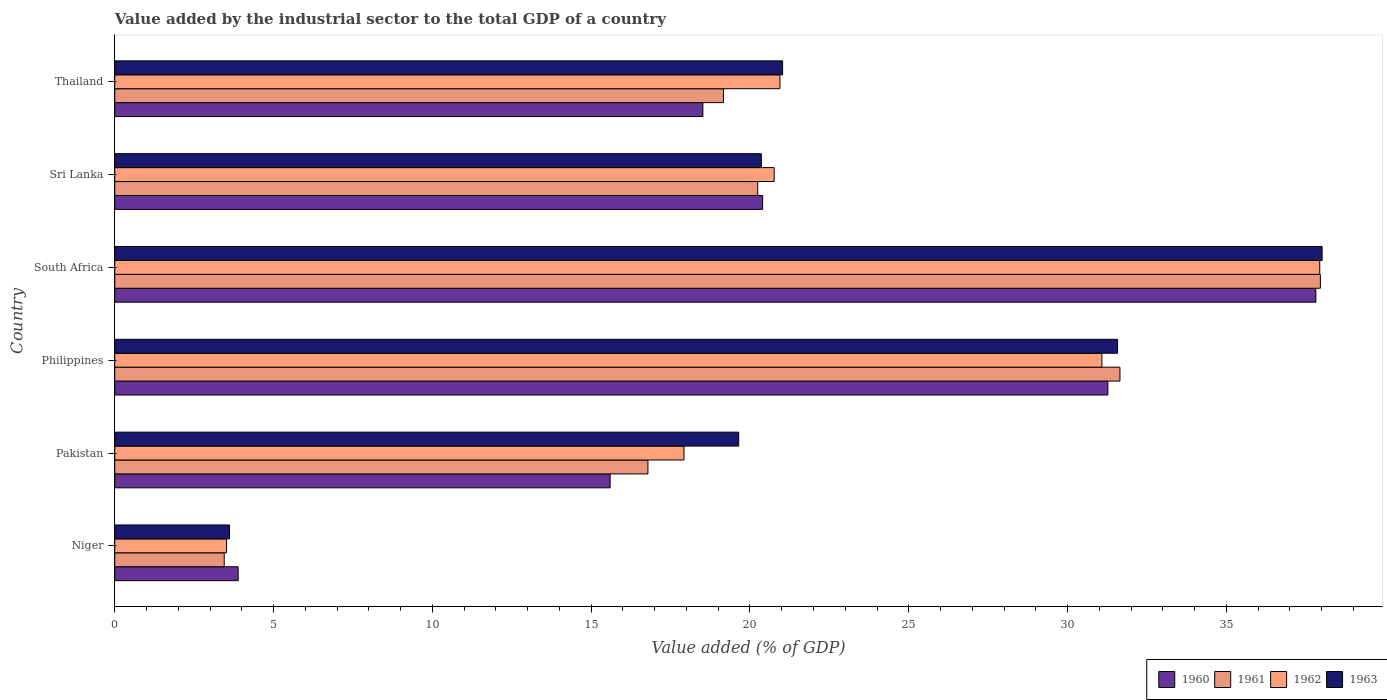How many groups of bars are there?
Ensure brevity in your answer.  6. Are the number of bars on each tick of the Y-axis equal?
Your response must be concise. Yes. How many bars are there on the 2nd tick from the top?
Give a very brief answer. 4. How many bars are there on the 2nd tick from the bottom?
Your answer should be compact. 4. What is the label of the 1st group of bars from the top?
Keep it short and to the point. Thailand. In how many cases, is the number of bars for a given country not equal to the number of legend labels?
Ensure brevity in your answer.  0. What is the value added by the industrial sector to the total GDP in 1962 in Thailand?
Give a very brief answer. 20.94. Across all countries, what is the maximum value added by the industrial sector to the total GDP in 1962?
Keep it short and to the point. 37.94. Across all countries, what is the minimum value added by the industrial sector to the total GDP in 1961?
Your answer should be very brief. 3.45. In which country was the value added by the industrial sector to the total GDP in 1961 maximum?
Your answer should be very brief. South Africa. In which country was the value added by the industrial sector to the total GDP in 1960 minimum?
Your answer should be compact. Niger. What is the total value added by the industrial sector to the total GDP in 1963 in the graph?
Your response must be concise. 134.23. What is the difference between the value added by the industrial sector to the total GDP in 1961 in Pakistan and that in Thailand?
Make the answer very short. -2.38. What is the difference between the value added by the industrial sector to the total GDP in 1960 in Niger and the value added by the industrial sector to the total GDP in 1961 in South Africa?
Offer a terse response. -34.07. What is the average value added by the industrial sector to the total GDP in 1960 per country?
Make the answer very short. 21.25. What is the difference between the value added by the industrial sector to the total GDP in 1963 and value added by the industrial sector to the total GDP in 1962 in Sri Lanka?
Provide a short and direct response. -0.4. What is the ratio of the value added by the industrial sector to the total GDP in 1960 in Philippines to that in Sri Lanka?
Your answer should be compact. 1.53. Is the value added by the industrial sector to the total GDP in 1961 in Pakistan less than that in Philippines?
Give a very brief answer. Yes. Is the difference between the value added by the industrial sector to the total GDP in 1963 in Niger and Philippines greater than the difference between the value added by the industrial sector to the total GDP in 1962 in Niger and Philippines?
Provide a succinct answer. No. What is the difference between the highest and the second highest value added by the industrial sector to the total GDP in 1963?
Make the answer very short. 6.44. What is the difference between the highest and the lowest value added by the industrial sector to the total GDP in 1962?
Offer a terse response. 34.42. In how many countries, is the value added by the industrial sector to the total GDP in 1960 greater than the average value added by the industrial sector to the total GDP in 1960 taken over all countries?
Keep it short and to the point. 2. Is it the case that in every country, the sum of the value added by the industrial sector to the total GDP in 1961 and value added by the industrial sector to the total GDP in 1960 is greater than the sum of value added by the industrial sector to the total GDP in 1963 and value added by the industrial sector to the total GDP in 1962?
Offer a very short reply. No. What does the 4th bar from the top in Philippines represents?
Offer a very short reply. 1960. Is it the case that in every country, the sum of the value added by the industrial sector to the total GDP in 1961 and value added by the industrial sector to the total GDP in 1962 is greater than the value added by the industrial sector to the total GDP in 1960?
Keep it short and to the point. Yes. How many bars are there?
Provide a short and direct response. 24. Does the graph contain any zero values?
Offer a very short reply. No. What is the title of the graph?
Provide a short and direct response. Value added by the industrial sector to the total GDP of a country. What is the label or title of the X-axis?
Your answer should be very brief. Value added (% of GDP). What is the label or title of the Y-axis?
Keep it short and to the point. Country. What is the Value added (% of GDP) in 1960 in Niger?
Offer a very short reply. 3.89. What is the Value added (% of GDP) of 1961 in Niger?
Provide a short and direct response. 3.45. What is the Value added (% of GDP) in 1962 in Niger?
Offer a terse response. 3.52. What is the Value added (% of GDP) of 1963 in Niger?
Offer a very short reply. 3.61. What is the Value added (% of GDP) of 1960 in Pakistan?
Offer a very short reply. 15.6. What is the Value added (% of GDP) of 1961 in Pakistan?
Give a very brief answer. 16.79. What is the Value added (% of GDP) in 1962 in Pakistan?
Keep it short and to the point. 17.92. What is the Value added (% of GDP) of 1963 in Pakistan?
Offer a terse response. 19.64. What is the Value added (% of GDP) in 1960 in Philippines?
Offer a terse response. 31.27. What is the Value added (% of GDP) of 1961 in Philippines?
Your answer should be compact. 31.65. What is the Value added (% of GDP) in 1962 in Philippines?
Make the answer very short. 31.08. What is the Value added (% of GDP) in 1963 in Philippines?
Give a very brief answer. 31.57. What is the Value added (% of GDP) in 1960 in South Africa?
Provide a short and direct response. 37.82. What is the Value added (% of GDP) in 1961 in South Africa?
Ensure brevity in your answer.  37.96. What is the Value added (% of GDP) in 1962 in South Africa?
Your response must be concise. 37.94. What is the Value added (% of GDP) in 1963 in South Africa?
Provide a short and direct response. 38.01. What is the Value added (% of GDP) of 1960 in Sri Lanka?
Keep it short and to the point. 20.4. What is the Value added (% of GDP) of 1961 in Sri Lanka?
Your answer should be very brief. 20.24. What is the Value added (% of GDP) in 1962 in Sri Lanka?
Your answer should be compact. 20.76. What is the Value added (% of GDP) in 1963 in Sri Lanka?
Offer a terse response. 20.36. What is the Value added (% of GDP) in 1960 in Thailand?
Provide a short and direct response. 18.52. What is the Value added (% of GDP) in 1961 in Thailand?
Your answer should be compact. 19.16. What is the Value added (% of GDP) in 1962 in Thailand?
Give a very brief answer. 20.94. What is the Value added (% of GDP) of 1963 in Thailand?
Your answer should be compact. 21.03. Across all countries, what is the maximum Value added (% of GDP) in 1960?
Offer a very short reply. 37.82. Across all countries, what is the maximum Value added (% of GDP) of 1961?
Give a very brief answer. 37.96. Across all countries, what is the maximum Value added (% of GDP) of 1962?
Give a very brief answer. 37.94. Across all countries, what is the maximum Value added (% of GDP) of 1963?
Keep it short and to the point. 38.01. Across all countries, what is the minimum Value added (% of GDP) of 1960?
Provide a succinct answer. 3.89. Across all countries, what is the minimum Value added (% of GDP) of 1961?
Ensure brevity in your answer.  3.45. Across all countries, what is the minimum Value added (% of GDP) of 1962?
Make the answer very short. 3.52. Across all countries, what is the minimum Value added (% of GDP) in 1963?
Your answer should be compact. 3.61. What is the total Value added (% of GDP) of 1960 in the graph?
Ensure brevity in your answer.  127.48. What is the total Value added (% of GDP) of 1961 in the graph?
Ensure brevity in your answer.  129.25. What is the total Value added (% of GDP) in 1962 in the graph?
Provide a short and direct response. 132.16. What is the total Value added (% of GDP) of 1963 in the graph?
Provide a succinct answer. 134.23. What is the difference between the Value added (% of GDP) in 1960 in Niger and that in Pakistan?
Provide a short and direct response. -11.71. What is the difference between the Value added (% of GDP) of 1961 in Niger and that in Pakistan?
Your answer should be compact. -13.34. What is the difference between the Value added (% of GDP) of 1962 in Niger and that in Pakistan?
Provide a succinct answer. -14.4. What is the difference between the Value added (% of GDP) in 1963 in Niger and that in Pakistan?
Ensure brevity in your answer.  -16.03. What is the difference between the Value added (% of GDP) in 1960 in Niger and that in Philippines?
Your answer should be compact. -27.38. What is the difference between the Value added (% of GDP) in 1961 in Niger and that in Philippines?
Ensure brevity in your answer.  -28.2. What is the difference between the Value added (% of GDP) in 1962 in Niger and that in Philippines?
Provide a succinct answer. -27.56. What is the difference between the Value added (% of GDP) in 1963 in Niger and that in Philippines?
Provide a short and direct response. -27.96. What is the difference between the Value added (% of GDP) in 1960 in Niger and that in South Africa?
Ensure brevity in your answer.  -33.93. What is the difference between the Value added (% of GDP) in 1961 in Niger and that in South Africa?
Your response must be concise. -34.51. What is the difference between the Value added (% of GDP) in 1962 in Niger and that in South Africa?
Provide a succinct answer. -34.42. What is the difference between the Value added (% of GDP) of 1963 in Niger and that in South Africa?
Your answer should be compact. -34.4. What is the difference between the Value added (% of GDP) of 1960 in Niger and that in Sri Lanka?
Provide a short and direct response. -16.51. What is the difference between the Value added (% of GDP) of 1961 in Niger and that in Sri Lanka?
Your response must be concise. -16.8. What is the difference between the Value added (% of GDP) in 1962 in Niger and that in Sri Lanka?
Ensure brevity in your answer.  -17.24. What is the difference between the Value added (% of GDP) in 1963 in Niger and that in Sri Lanka?
Your answer should be very brief. -16.74. What is the difference between the Value added (% of GDP) of 1960 in Niger and that in Thailand?
Offer a very short reply. -14.63. What is the difference between the Value added (% of GDP) of 1961 in Niger and that in Thailand?
Offer a very short reply. -15.72. What is the difference between the Value added (% of GDP) of 1962 in Niger and that in Thailand?
Your answer should be compact. -17.42. What is the difference between the Value added (% of GDP) of 1963 in Niger and that in Thailand?
Give a very brief answer. -17.41. What is the difference between the Value added (% of GDP) of 1960 in Pakistan and that in Philippines?
Make the answer very short. -15.67. What is the difference between the Value added (% of GDP) in 1961 in Pakistan and that in Philippines?
Provide a succinct answer. -14.86. What is the difference between the Value added (% of GDP) in 1962 in Pakistan and that in Philippines?
Ensure brevity in your answer.  -13.16. What is the difference between the Value added (% of GDP) of 1963 in Pakistan and that in Philippines?
Provide a succinct answer. -11.93. What is the difference between the Value added (% of GDP) of 1960 in Pakistan and that in South Africa?
Give a very brief answer. -22.22. What is the difference between the Value added (% of GDP) of 1961 in Pakistan and that in South Africa?
Offer a very short reply. -21.17. What is the difference between the Value added (% of GDP) in 1962 in Pakistan and that in South Africa?
Your answer should be very brief. -20.02. What is the difference between the Value added (% of GDP) of 1963 in Pakistan and that in South Africa?
Keep it short and to the point. -18.37. What is the difference between the Value added (% of GDP) of 1960 in Pakistan and that in Sri Lanka?
Keep it short and to the point. -4.8. What is the difference between the Value added (% of GDP) of 1961 in Pakistan and that in Sri Lanka?
Give a very brief answer. -3.46. What is the difference between the Value added (% of GDP) of 1962 in Pakistan and that in Sri Lanka?
Keep it short and to the point. -2.84. What is the difference between the Value added (% of GDP) in 1963 in Pakistan and that in Sri Lanka?
Ensure brevity in your answer.  -0.71. What is the difference between the Value added (% of GDP) in 1960 in Pakistan and that in Thailand?
Your answer should be very brief. -2.92. What is the difference between the Value added (% of GDP) of 1961 in Pakistan and that in Thailand?
Provide a short and direct response. -2.38. What is the difference between the Value added (% of GDP) of 1962 in Pakistan and that in Thailand?
Provide a succinct answer. -3.02. What is the difference between the Value added (% of GDP) of 1963 in Pakistan and that in Thailand?
Ensure brevity in your answer.  -1.38. What is the difference between the Value added (% of GDP) of 1960 in Philippines and that in South Africa?
Your answer should be compact. -6.55. What is the difference between the Value added (% of GDP) in 1961 in Philippines and that in South Africa?
Provide a short and direct response. -6.31. What is the difference between the Value added (% of GDP) of 1962 in Philippines and that in South Africa?
Provide a short and direct response. -6.86. What is the difference between the Value added (% of GDP) in 1963 in Philippines and that in South Africa?
Give a very brief answer. -6.44. What is the difference between the Value added (% of GDP) in 1960 in Philippines and that in Sri Lanka?
Ensure brevity in your answer.  10.87. What is the difference between the Value added (% of GDP) of 1961 in Philippines and that in Sri Lanka?
Give a very brief answer. 11.41. What is the difference between the Value added (% of GDP) in 1962 in Philippines and that in Sri Lanka?
Your answer should be compact. 10.32. What is the difference between the Value added (% of GDP) in 1963 in Philippines and that in Sri Lanka?
Ensure brevity in your answer.  11.22. What is the difference between the Value added (% of GDP) in 1960 in Philippines and that in Thailand?
Offer a terse response. 12.75. What is the difference between the Value added (% of GDP) of 1961 in Philippines and that in Thailand?
Offer a very short reply. 12.48. What is the difference between the Value added (% of GDP) of 1962 in Philippines and that in Thailand?
Your answer should be compact. 10.14. What is the difference between the Value added (% of GDP) in 1963 in Philippines and that in Thailand?
Offer a terse response. 10.55. What is the difference between the Value added (% of GDP) in 1960 in South Africa and that in Sri Lanka?
Your answer should be compact. 17.42. What is the difference between the Value added (% of GDP) in 1961 in South Africa and that in Sri Lanka?
Offer a terse response. 17.72. What is the difference between the Value added (% of GDP) in 1962 in South Africa and that in Sri Lanka?
Give a very brief answer. 17.18. What is the difference between the Value added (% of GDP) in 1963 in South Africa and that in Sri Lanka?
Provide a short and direct response. 17.66. What is the difference between the Value added (% of GDP) of 1960 in South Africa and that in Thailand?
Give a very brief answer. 19.3. What is the difference between the Value added (% of GDP) of 1961 in South Africa and that in Thailand?
Your response must be concise. 18.79. What is the difference between the Value added (% of GDP) of 1962 in South Africa and that in Thailand?
Offer a terse response. 17. What is the difference between the Value added (% of GDP) in 1963 in South Africa and that in Thailand?
Your answer should be compact. 16.99. What is the difference between the Value added (% of GDP) in 1960 in Sri Lanka and that in Thailand?
Provide a succinct answer. 1.88. What is the difference between the Value added (% of GDP) in 1961 in Sri Lanka and that in Thailand?
Make the answer very short. 1.08. What is the difference between the Value added (% of GDP) in 1962 in Sri Lanka and that in Thailand?
Your response must be concise. -0.18. What is the difference between the Value added (% of GDP) of 1963 in Sri Lanka and that in Thailand?
Your answer should be very brief. -0.67. What is the difference between the Value added (% of GDP) of 1960 in Niger and the Value added (% of GDP) of 1961 in Pakistan?
Offer a terse response. -12.9. What is the difference between the Value added (% of GDP) of 1960 in Niger and the Value added (% of GDP) of 1962 in Pakistan?
Provide a short and direct response. -14.04. What is the difference between the Value added (% of GDP) in 1960 in Niger and the Value added (% of GDP) in 1963 in Pakistan?
Make the answer very short. -15.76. What is the difference between the Value added (% of GDP) of 1961 in Niger and the Value added (% of GDP) of 1962 in Pakistan?
Your answer should be very brief. -14.48. What is the difference between the Value added (% of GDP) of 1961 in Niger and the Value added (% of GDP) of 1963 in Pakistan?
Offer a terse response. -16.2. What is the difference between the Value added (% of GDP) in 1962 in Niger and the Value added (% of GDP) in 1963 in Pakistan?
Give a very brief answer. -16.12. What is the difference between the Value added (% of GDP) of 1960 in Niger and the Value added (% of GDP) of 1961 in Philippines?
Provide a short and direct response. -27.76. What is the difference between the Value added (% of GDP) in 1960 in Niger and the Value added (% of GDP) in 1962 in Philippines?
Ensure brevity in your answer.  -27.19. What is the difference between the Value added (% of GDP) in 1960 in Niger and the Value added (% of GDP) in 1963 in Philippines?
Provide a short and direct response. -27.69. What is the difference between the Value added (% of GDP) in 1961 in Niger and the Value added (% of GDP) in 1962 in Philippines?
Provide a succinct answer. -27.63. What is the difference between the Value added (% of GDP) of 1961 in Niger and the Value added (% of GDP) of 1963 in Philippines?
Make the answer very short. -28.13. What is the difference between the Value added (% of GDP) of 1962 in Niger and the Value added (% of GDP) of 1963 in Philippines?
Give a very brief answer. -28.05. What is the difference between the Value added (% of GDP) in 1960 in Niger and the Value added (% of GDP) in 1961 in South Africa?
Your answer should be compact. -34.07. What is the difference between the Value added (% of GDP) of 1960 in Niger and the Value added (% of GDP) of 1962 in South Africa?
Offer a very short reply. -34.05. What is the difference between the Value added (% of GDP) of 1960 in Niger and the Value added (% of GDP) of 1963 in South Africa?
Offer a very short reply. -34.13. What is the difference between the Value added (% of GDP) of 1961 in Niger and the Value added (% of GDP) of 1962 in South Africa?
Ensure brevity in your answer.  -34.49. What is the difference between the Value added (% of GDP) of 1961 in Niger and the Value added (% of GDP) of 1963 in South Africa?
Your answer should be compact. -34.57. What is the difference between the Value added (% of GDP) of 1962 in Niger and the Value added (% of GDP) of 1963 in South Africa?
Keep it short and to the point. -34.49. What is the difference between the Value added (% of GDP) in 1960 in Niger and the Value added (% of GDP) in 1961 in Sri Lanka?
Provide a short and direct response. -16.36. What is the difference between the Value added (% of GDP) of 1960 in Niger and the Value added (% of GDP) of 1962 in Sri Lanka?
Provide a succinct answer. -16.88. What is the difference between the Value added (% of GDP) in 1960 in Niger and the Value added (% of GDP) in 1963 in Sri Lanka?
Keep it short and to the point. -16.47. What is the difference between the Value added (% of GDP) in 1961 in Niger and the Value added (% of GDP) in 1962 in Sri Lanka?
Your answer should be very brief. -17.32. What is the difference between the Value added (% of GDP) of 1961 in Niger and the Value added (% of GDP) of 1963 in Sri Lanka?
Give a very brief answer. -16.91. What is the difference between the Value added (% of GDP) in 1962 in Niger and the Value added (% of GDP) in 1963 in Sri Lanka?
Keep it short and to the point. -16.84. What is the difference between the Value added (% of GDP) in 1960 in Niger and the Value added (% of GDP) in 1961 in Thailand?
Keep it short and to the point. -15.28. What is the difference between the Value added (% of GDP) in 1960 in Niger and the Value added (% of GDP) in 1962 in Thailand?
Make the answer very short. -17.06. What is the difference between the Value added (% of GDP) of 1960 in Niger and the Value added (% of GDP) of 1963 in Thailand?
Your answer should be compact. -17.14. What is the difference between the Value added (% of GDP) in 1961 in Niger and the Value added (% of GDP) in 1962 in Thailand?
Your answer should be very brief. -17.5. What is the difference between the Value added (% of GDP) in 1961 in Niger and the Value added (% of GDP) in 1963 in Thailand?
Your response must be concise. -17.58. What is the difference between the Value added (% of GDP) of 1962 in Niger and the Value added (% of GDP) of 1963 in Thailand?
Make the answer very short. -17.51. What is the difference between the Value added (% of GDP) of 1960 in Pakistan and the Value added (% of GDP) of 1961 in Philippines?
Your answer should be compact. -16.05. What is the difference between the Value added (% of GDP) in 1960 in Pakistan and the Value added (% of GDP) in 1962 in Philippines?
Ensure brevity in your answer.  -15.48. What is the difference between the Value added (% of GDP) in 1960 in Pakistan and the Value added (% of GDP) in 1963 in Philippines?
Your answer should be compact. -15.98. What is the difference between the Value added (% of GDP) in 1961 in Pakistan and the Value added (% of GDP) in 1962 in Philippines?
Give a very brief answer. -14.29. What is the difference between the Value added (% of GDP) in 1961 in Pakistan and the Value added (% of GDP) in 1963 in Philippines?
Give a very brief answer. -14.79. What is the difference between the Value added (% of GDP) in 1962 in Pakistan and the Value added (% of GDP) in 1963 in Philippines?
Provide a succinct answer. -13.65. What is the difference between the Value added (% of GDP) in 1960 in Pakistan and the Value added (% of GDP) in 1961 in South Africa?
Offer a terse response. -22.36. What is the difference between the Value added (% of GDP) of 1960 in Pakistan and the Value added (% of GDP) of 1962 in South Africa?
Give a very brief answer. -22.34. What is the difference between the Value added (% of GDP) of 1960 in Pakistan and the Value added (% of GDP) of 1963 in South Africa?
Your answer should be very brief. -22.42. What is the difference between the Value added (% of GDP) in 1961 in Pakistan and the Value added (% of GDP) in 1962 in South Africa?
Offer a terse response. -21.15. What is the difference between the Value added (% of GDP) in 1961 in Pakistan and the Value added (% of GDP) in 1963 in South Africa?
Ensure brevity in your answer.  -21.23. What is the difference between the Value added (% of GDP) of 1962 in Pakistan and the Value added (% of GDP) of 1963 in South Africa?
Keep it short and to the point. -20.09. What is the difference between the Value added (% of GDP) in 1960 in Pakistan and the Value added (% of GDP) in 1961 in Sri Lanka?
Give a very brief answer. -4.65. What is the difference between the Value added (% of GDP) of 1960 in Pakistan and the Value added (% of GDP) of 1962 in Sri Lanka?
Ensure brevity in your answer.  -5.16. What is the difference between the Value added (% of GDP) of 1960 in Pakistan and the Value added (% of GDP) of 1963 in Sri Lanka?
Provide a succinct answer. -4.76. What is the difference between the Value added (% of GDP) of 1961 in Pakistan and the Value added (% of GDP) of 1962 in Sri Lanka?
Give a very brief answer. -3.97. What is the difference between the Value added (% of GDP) of 1961 in Pakistan and the Value added (% of GDP) of 1963 in Sri Lanka?
Provide a short and direct response. -3.57. What is the difference between the Value added (% of GDP) of 1962 in Pakistan and the Value added (% of GDP) of 1963 in Sri Lanka?
Your answer should be very brief. -2.44. What is the difference between the Value added (% of GDP) of 1960 in Pakistan and the Value added (% of GDP) of 1961 in Thailand?
Provide a short and direct response. -3.57. What is the difference between the Value added (% of GDP) of 1960 in Pakistan and the Value added (% of GDP) of 1962 in Thailand?
Give a very brief answer. -5.35. What is the difference between the Value added (% of GDP) in 1960 in Pakistan and the Value added (% of GDP) in 1963 in Thailand?
Your answer should be very brief. -5.43. What is the difference between the Value added (% of GDP) of 1961 in Pakistan and the Value added (% of GDP) of 1962 in Thailand?
Ensure brevity in your answer.  -4.16. What is the difference between the Value added (% of GDP) in 1961 in Pakistan and the Value added (% of GDP) in 1963 in Thailand?
Give a very brief answer. -4.24. What is the difference between the Value added (% of GDP) of 1962 in Pakistan and the Value added (% of GDP) of 1963 in Thailand?
Your answer should be compact. -3.11. What is the difference between the Value added (% of GDP) of 1960 in Philippines and the Value added (% of GDP) of 1961 in South Africa?
Offer a very short reply. -6.69. What is the difference between the Value added (% of GDP) of 1960 in Philippines and the Value added (% of GDP) of 1962 in South Africa?
Your response must be concise. -6.67. What is the difference between the Value added (% of GDP) of 1960 in Philippines and the Value added (% of GDP) of 1963 in South Africa?
Give a very brief answer. -6.75. What is the difference between the Value added (% of GDP) of 1961 in Philippines and the Value added (% of GDP) of 1962 in South Africa?
Provide a succinct answer. -6.29. What is the difference between the Value added (% of GDP) of 1961 in Philippines and the Value added (% of GDP) of 1963 in South Africa?
Offer a terse response. -6.37. What is the difference between the Value added (% of GDP) in 1962 in Philippines and the Value added (% of GDP) in 1963 in South Africa?
Provide a succinct answer. -6.93. What is the difference between the Value added (% of GDP) in 1960 in Philippines and the Value added (% of GDP) in 1961 in Sri Lanka?
Your response must be concise. 11.03. What is the difference between the Value added (% of GDP) of 1960 in Philippines and the Value added (% of GDP) of 1962 in Sri Lanka?
Your answer should be very brief. 10.51. What is the difference between the Value added (% of GDP) in 1960 in Philippines and the Value added (% of GDP) in 1963 in Sri Lanka?
Your answer should be very brief. 10.91. What is the difference between the Value added (% of GDP) of 1961 in Philippines and the Value added (% of GDP) of 1962 in Sri Lanka?
Make the answer very short. 10.89. What is the difference between the Value added (% of GDP) of 1961 in Philippines and the Value added (% of GDP) of 1963 in Sri Lanka?
Provide a short and direct response. 11.29. What is the difference between the Value added (% of GDP) in 1962 in Philippines and the Value added (% of GDP) in 1963 in Sri Lanka?
Make the answer very short. 10.72. What is the difference between the Value added (% of GDP) in 1960 in Philippines and the Value added (% of GDP) in 1961 in Thailand?
Give a very brief answer. 12.1. What is the difference between the Value added (% of GDP) in 1960 in Philippines and the Value added (% of GDP) in 1962 in Thailand?
Make the answer very short. 10.33. What is the difference between the Value added (% of GDP) of 1960 in Philippines and the Value added (% of GDP) of 1963 in Thailand?
Your answer should be compact. 10.24. What is the difference between the Value added (% of GDP) in 1961 in Philippines and the Value added (% of GDP) in 1962 in Thailand?
Keep it short and to the point. 10.71. What is the difference between the Value added (% of GDP) of 1961 in Philippines and the Value added (% of GDP) of 1963 in Thailand?
Your answer should be compact. 10.62. What is the difference between the Value added (% of GDP) in 1962 in Philippines and the Value added (% of GDP) in 1963 in Thailand?
Your response must be concise. 10.05. What is the difference between the Value added (% of GDP) of 1960 in South Africa and the Value added (% of GDP) of 1961 in Sri Lanka?
Offer a terse response. 17.57. What is the difference between the Value added (% of GDP) of 1960 in South Africa and the Value added (% of GDP) of 1962 in Sri Lanka?
Keep it short and to the point. 17.06. What is the difference between the Value added (% of GDP) of 1960 in South Africa and the Value added (% of GDP) of 1963 in Sri Lanka?
Ensure brevity in your answer.  17.46. What is the difference between the Value added (% of GDP) of 1961 in South Africa and the Value added (% of GDP) of 1962 in Sri Lanka?
Ensure brevity in your answer.  17.2. What is the difference between the Value added (% of GDP) of 1961 in South Africa and the Value added (% of GDP) of 1963 in Sri Lanka?
Your answer should be compact. 17.6. What is the difference between the Value added (% of GDP) of 1962 in South Africa and the Value added (% of GDP) of 1963 in Sri Lanka?
Offer a terse response. 17.58. What is the difference between the Value added (% of GDP) of 1960 in South Africa and the Value added (% of GDP) of 1961 in Thailand?
Offer a very short reply. 18.65. What is the difference between the Value added (% of GDP) in 1960 in South Africa and the Value added (% of GDP) in 1962 in Thailand?
Your response must be concise. 16.87. What is the difference between the Value added (% of GDP) of 1960 in South Africa and the Value added (% of GDP) of 1963 in Thailand?
Your answer should be very brief. 16.79. What is the difference between the Value added (% of GDP) of 1961 in South Africa and the Value added (% of GDP) of 1962 in Thailand?
Your answer should be compact. 17.02. What is the difference between the Value added (% of GDP) in 1961 in South Africa and the Value added (% of GDP) in 1963 in Thailand?
Your response must be concise. 16.93. What is the difference between the Value added (% of GDP) in 1962 in South Africa and the Value added (% of GDP) in 1963 in Thailand?
Provide a short and direct response. 16.91. What is the difference between the Value added (% of GDP) of 1960 in Sri Lanka and the Value added (% of GDP) of 1961 in Thailand?
Offer a terse response. 1.23. What is the difference between the Value added (% of GDP) in 1960 in Sri Lanka and the Value added (% of GDP) in 1962 in Thailand?
Ensure brevity in your answer.  -0.54. What is the difference between the Value added (% of GDP) in 1960 in Sri Lanka and the Value added (% of GDP) in 1963 in Thailand?
Make the answer very short. -0.63. What is the difference between the Value added (% of GDP) of 1961 in Sri Lanka and the Value added (% of GDP) of 1962 in Thailand?
Your answer should be compact. -0.7. What is the difference between the Value added (% of GDP) in 1961 in Sri Lanka and the Value added (% of GDP) in 1963 in Thailand?
Your answer should be very brief. -0.78. What is the difference between the Value added (% of GDP) of 1962 in Sri Lanka and the Value added (% of GDP) of 1963 in Thailand?
Your response must be concise. -0.27. What is the average Value added (% of GDP) of 1960 per country?
Offer a terse response. 21.25. What is the average Value added (% of GDP) of 1961 per country?
Your answer should be very brief. 21.54. What is the average Value added (% of GDP) of 1962 per country?
Ensure brevity in your answer.  22.03. What is the average Value added (% of GDP) in 1963 per country?
Ensure brevity in your answer.  22.37. What is the difference between the Value added (% of GDP) of 1960 and Value added (% of GDP) of 1961 in Niger?
Provide a succinct answer. 0.44. What is the difference between the Value added (% of GDP) of 1960 and Value added (% of GDP) of 1962 in Niger?
Offer a very short reply. 0.37. What is the difference between the Value added (% of GDP) of 1960 and Value added (% of GDP) of 1963 in Niger?
Offer a terse response. 0.27. What is the difference between the Value added (% of GDP) in 1961 and Value added (% of GDP) in 1962 in Niger?
Provide a short and direct response. -0.07. What is the difference between the Value added (% of GDP) of 1961 and Value added (% of GDP) of 1963 in Niger?
Your response must be concise. -0.17. What is the difference between the Value added (% of GDP) in 1962 and Value added (% of GDP) in 1963 in Niger?
Offer a very short reply. -0.09. What is the difference between the Value added (% of GDP) of 1960 and Value added (% of GDP) of 1961 in Pakistan?
Make the answer very short. -1.19. What is the difference between the Value added (% of GDP) in 1960 and Value added (% of GDP) in 1962 in Pakistan?
Give a very brief answer. -2.33. What is the difference between the Value added (% of GDP) in 1960 and Value added (% of GDP) in 1963 in Pakistan?
Provide a short and direct response. -4.05. What is the difference between the Value added (% of GDP) in 1961 and Value added (% of GDP) in 1962 in Pakistan?
Ensure brevity in your answer.  -1.14. What is the difference between the Value added (% of GDP) in 1961 and Value added (% of GDP) in 1963 in Pakistan?
Your response must be concise. -2.86. What is the difference between the Value added (% of GDP) of 1962 and Value added (% of GDP) of 1963 in Pakistan?
Provide a succinct answer. -1.72. What is the difference between the Value added (% of GDP) in 1960 and Value added (% of GDP) in 1961 in Philippines?
Offer a very short reply. -0.38. What is the difference between the Value added (% of GDP) of 1960 and Value added (% of GDP) of 1962 in Philippines?
Offer a terse response. 0.19. What is the difference between the Value added (% of GDP) of 1960 and Value added (% of GDP) of 1963 in Philippines?
Your answer should be compact. -0.3. What is the difference between the Value added (% of GDP) in 1961 and Value added (% of GDP) in 1962 in Philippines?
Make the answer very short. 0.57. What is the difference between the Value added (% of GDP) of 1961 and Value added (% of GDP) of 1963 in Philippines?
Your answer should be very brief. 0.08. What is the difference between the Value added (% of GDP) in 1962 and Value added (% of GDP) in 1963 in Philippines?
Your answer should be compact. -0.49. What is the difference between the Value added (% of GDP) in 1960 and Value added (% of GDP) in 1961 in South Africa?
Offer a very short reply. -0.14. What is the difference between the Value added (% of GDP) of 1960 and Value added (% of GDP) of 1962 in South Africa?
Your response must be concise. -0.12. What is the difference between the Value added (% of GDP) of 1960 and Value added (% of GDP) of 1963 in South Africa?
Your response must be concise. -0.2. What is the difference between the Value added (% of GDP) in 1961 and Value added (% of GDP) in 1962 in South Africa?
Your answer should be compact. 0.02. What is the difference between the Value added (% of GDP) of 1961 and Value added (% of GDP) of 1963 in South Africa?
Your answer should be compact. -0.05. What is the difference between the Value added (% of GDP) of 1962 and Value added (% of GDP) of 1963 in South Africa?
Your answer should be compact. -0.08. What is the difference between the Value added (% of GDP) in 1960 and Value added (% of GDP) in 1961 in Sri Lanka?
Provide a succinct answer. 0.16. What is the difference between the Value added (% of GDP) of 1960 and Value added (% of GDP) of 1962 in Sri Lanka?
Provide a succinct answer. -0.36. What is the difference between the Value added (% of GDP) of 1960 and Value added (% of GDP) of 1963 in Sri Lanka?
Keep it short and to the point. 0.04. What is the difference between the Value added (% of GDP) of 1961 and Value added (% of GDP) of 1962 in Sri Lanka?
Offer a very short reply. -0.52. What is the difference between the Value added (% of GDP) in 1961 and Value added (% of GDP) in 1963 in Sri Lanka?
Your answer should be compact. -0.11. What is the difference between the Value added (% of GDP) in 1962 and Value added (% of GDP) in 1963 in Sri Lanka?
Offer a very short reply. 0.4. What is the difference between the Value added (% of GDP) of 1960 and Value added (% of GDP) of 1961 in Thailand?
Your response must be concise. -0.65. What is the difference between the Value added (% of GDP) in 1960 and Value added (% of GDP) in 1962 in Thailand?
Your answer should be very brief. -2.43. What is the difference between the Value added (% of GDP) in 1960 and Value added (% of GDP) in 1963 in Thailand?
Your response must be concise. -2.51. What is the difference between the Value added (% of GDP) in 1961 and Value added (% of GDP) in 1962 in Thailand?
Offer a terse response. -1.78. What is the difference between the Value added (% of GDP) in 1961 and Value added (% of GDP) in 1963 in Thailand?
Your answer should be very brief. -1.86. What is the difference between the Value added (% of GDP) in 1962 and Value added (% of GDP) in 1963 in Thailand?
Provide a succinct answer. -0.08. What is the ratio of the Value added (% of GDP) in 1960 in Niger to that in Pakistan?
Your answer should be very brief. 0.25. What is the ratio of the Value added (% of GDP) in 1961 in Niger to that in Pakistan?
Offer a very short reply. 0.21. What is the ratio of the Value added (% of GDP) in 1962 in Niger to that in Pakistan?
Offer a terse response. 0.2. What is the ratio of the Value added (% of GDP) in 1963 in Niger to that in Pakistan?
Give a very brief answer. 0.18. What is the ratio of the Value added (% of GDP) in 1960 in Niger to that in Philippines?
Offer a terse response. 0.12. What is the ratio of the Value added (% of GDP) in 1961 in Niger to that in Philippines?
Make the answer very short. 0.11. What is the ratio of the Value added (% of GDP) of 1962 in Niger to that in Philippines?
Provide a succinct answer. 0.11. What is the ratio of the Value added (% of GDP) in 1963 in Niger to that in Philippines?
Offer a terse response. 0.11. What is the ratio of the Value added (% of GDP) in 1960 in Niger to that in South Africa?
Offer a terse response. 0.1. What is the ratio of the Value added (% of GDP) of 1961 in Niger to that in South Africa?
Your response must be concise. 0.09. What is the ratio of the Value added (% of GDP) of 1962 in Niger to that in South Africa?
Make the answer very short. 0.09. What is the ratio of the Value added (% of GDP) of 1963 in Niger to that in South Africa?
Ensure brevity in your answer.  0.1. What is the ratio of the Value added (% of GDP) in 1960 in Niger to that in Sri Lanka?
Offer a very short reply. 0.19. What is the ratio of the Value added (% of GDP) of 1961 in Niger to that in Sri Lanka?
Your response must be concise. 0.17. What is the ratio of the Value added (% of GDP) of 1962 in Niger to that in Sri Lanka?
Your response must be concise. 0.17. What is the ratio of the Value added (% of GDP) in 1963 in Niger to that in Sri Lanka?
Provide a short and direct response. 0.18. What is the ratio of the Value added (% of GDP) of 1960 in Niger to that in Thailand?
Give a very brief answer. 0.21. What is the ratio of the Value added (% of GDP) of 1961 in Niger to that in Thailand?
Your response must be concise. 0.18. What is the ratio of the Value added (% of GDP) in 1962 in Niger to that in Thailand?
Provide a short and direct response. 0.17. What is the ratio of the Value added (% of GDP) in 1963 in Niger to that in Thailand?
Provide a short and direct response. 0.17. What is the ratio of the Value added (% of GDP) of 1960 in Pakistan to that in Philippines?
Your answer should be compact. 0.5. What is the ratio of the Value added (% of GDP) of 1961 in Pakistan to that in Philippines?
Keep it short and to the point. 0.53. What is the ratio of the Value added (% of GDP) of 1962 in Pakistan to that in Philippines?
Offer a terse response. 0.58. What is the ratio of the Value added (% of GDP) in 1963 in Pakistan to that in Philippines?
Your answer should be very brief. 0.62. What is the ratio of the Value added (% of GDP) in 1960 in Pakistan to that in South Africa?
Offer a very short reply. 0.41. What is the ratio of the Value added (% of GDP) of 1961 in Pakistan to that in South Africa?
Your response must be concise. 0.44. What is the ratio of the Value added (% of GDP) of 1962 in Pakistan to that in South Africa?
Offer a very short reply. 0.47. What is the ratio of the Value added (% of GDP) of 1963 in Pakistan to that in South Africa?
Your response must be concise. 0.52. What is the ratio of the Value added (% of GDP) of 1960 in Pakistan to that in Sri Lanka?
Offer a terse response. 0.76. What is the ratio of the Value added (% of GDP) of 1961 in Pakistan to that in Sri Lanka?
Your answer should be compact. 0.83. What is the ratio of the Value added (% of GDP) of 1962 in Pakistan to that in Sri Lanka?
Make the answer very short. 0.86. What is the ratio of the Value added (% of GDP) of 1963 in Pakistan to that in Sri Lanka?
Your answer should be compact. 0.96. What is the ratio of the Value added (% of GDP) in 1960 in Pakistan to that in Thailand?
Ensure brevity in your answer.  0.84. What is the ratio of the Value added (% of GDP) in 1961 in Pakistan to that in Thailand?
Ensure brevity in your answer.  0.88. What is the ratio of the Value added (% of GDP) in 1962 in Pakistan to that in Thailand?
Offer a terse response. 0.86. What is the ratio of the Value added (% of GDP) in 1963 in Pakistan to that in Thailand?
Offer a very short reply. 0.93. What is the ratio of the Value added (% of GDP) in 1960 in Philippines to that in South Africa?
Keep it short and to the point. 0.83. What is the ratio of the Value added (% of GDP) in 1961 in Philippines to that in South Africa?
Give a very brief answer. 0.83. What is the ratio of the Value added (% of GDP) in 1962 in Philippines to that in South Africa?
Provide a succinct answer. 0.82. What is the ratio of the Value added (% of GDP) of 1963 in Philippines to that in South Africa?
Your answer should be very brief. 0.83. What is the ratio of the Value added (% of GDP) of 1960 in Philippines to that in Sri Lanka?
Make the answer very short. 1.53. What is the ratio of the Value added (% of GDP) in 1961 in Philippines to that in Sri Lanka?
Offer a terse response. 1.56. What is the ratio of the Value added (% of GDP) of 1962 in Philippines to that in Sri Lanka?
Make the answer very short. 1.5. What is the ratio of the Value added (% of GDP) of 1963 in Philippines to that in Sri Lanka?
Offer a terse response. 1.55. What is the ratio of the Value added (% of GDP) in 1960 in Philippines to that in Thailand?
Offer a terse response. 1.69. What is the ratio of the Value added (% of GDP) in 1961 in Philippines to that in Thailand?
Keep it short and to the point. 1.65. What is the ratio of the Value added (% of GDP) of 1962 in Philippines to that in Thailand?
Provide a succinct answer. 1.48. What is the ratio of the Value added (% of GDP) in 1963 in Philippines to that in Thailand?
Give a very brief answer. 1.5. What is the ratio of the Value added (% of GDP) in 1960 in South Africa to that in Sri Lanka?
Provide a succinct answer. 1.85. What is the ratio of the Value added (% of GDP) in 1961 in South Africa to that in Sri Lanka?
Ensure brevity in your answer.  1.88. What is the ratio of the Value added (% of GDP) in 1962 in South Africa to that in Sri Lanka?
Ensure brevity in your answer.  1.83. What is the ratio of the Value added (% of GDP) of 1963 in South Africa to that in Sri Lanka?
Ensure brevity in your answer.  1.87. What is the ratio of the Value added (% of GDP) in 1960 in South Africa to that in Thailand?
Your answer should be compact. 2.04. What is the ratio of the Value added (% of GDP) of 1961 in South Africa to that in Thailand?
Keep it short and to the point. 1.98. What is the ratio of the Value added (% of GDP) of 1962 in South Africa to that in Thailand?
Ensure brevity in your answer.  1.81. What is the ratio of the Value added (% of GDP) of 1963 in South Africa to that in Thailand?
Give a very brief answer. 1.81. What is the ratio of the Value added (% of GDP) of 1960 in Sri Lanka to that in Thailand?
Give a very brief answer. 1.1. What is the ratio of the Value added (% of GDP) in 1961 in Sri Lanka to that in Thailand?
Ensure brevity in your answer.  1.06. What is the ratio of the Value added (% of GDP) of 1962 in Sri Lanka to that in Thailand?
Give a very brief answer. 0.99. What is the ratio of the Value added (% of GDP) of 1963 in Sri Lanka to that in Thailand?
Provide a succinct answer. 0.97. What is the difference between the highest and the second highest Value added (% of GDP) of 1960?
Your response must be concise. 6.55. What is the difference between the highest and the second highest Value added (% of GDP) of 1961?
Keep it short and to the point. 6.31. What is the difference between the highest and the second highest Value added (% of GDP) in 1962?
Make the answer very short. 6.86. What is the difference between the highest and the second highest Value added (% of GDP) of 1963?
Keep it short and to the point. 6.44. What is the difference between the highest and the lowest Value added (% of GDP) in 1960?
Provide a succinct answer. 33.93. What is the difference between the highest and the lowest Value added (% of GDP) in 1961?
Offer a terse response. 34.51. What is the difference between the highest and the lowest Value added (% of GDP) of 1962?
Make the answer very short. 34.42. What is the difference between the highest and the lowest Value added (% of GDP) of 1963?
Ensure brevity in your answer.  34.4. 